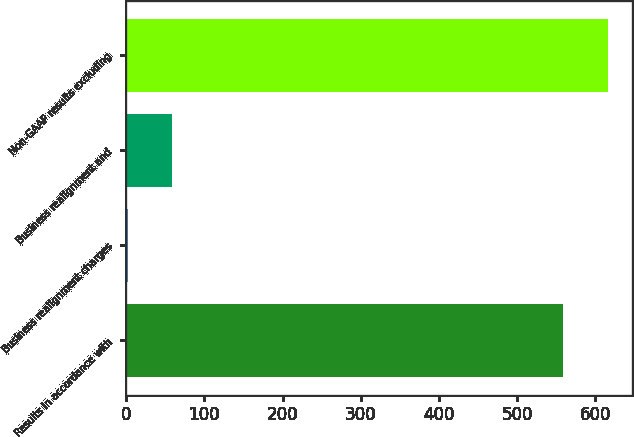Convert chart. <chart><loc_0><loc_0><loc_500><loc_500><bar_chart><fcel>Results in accordance with<fcel>Business realignment charges<fcel>Business realignment and<fcel>Non-GAAP results excluding<nl><fcel>559.1<fcel>2<fcel>58.46<fcel>615.56<nl></chart> 